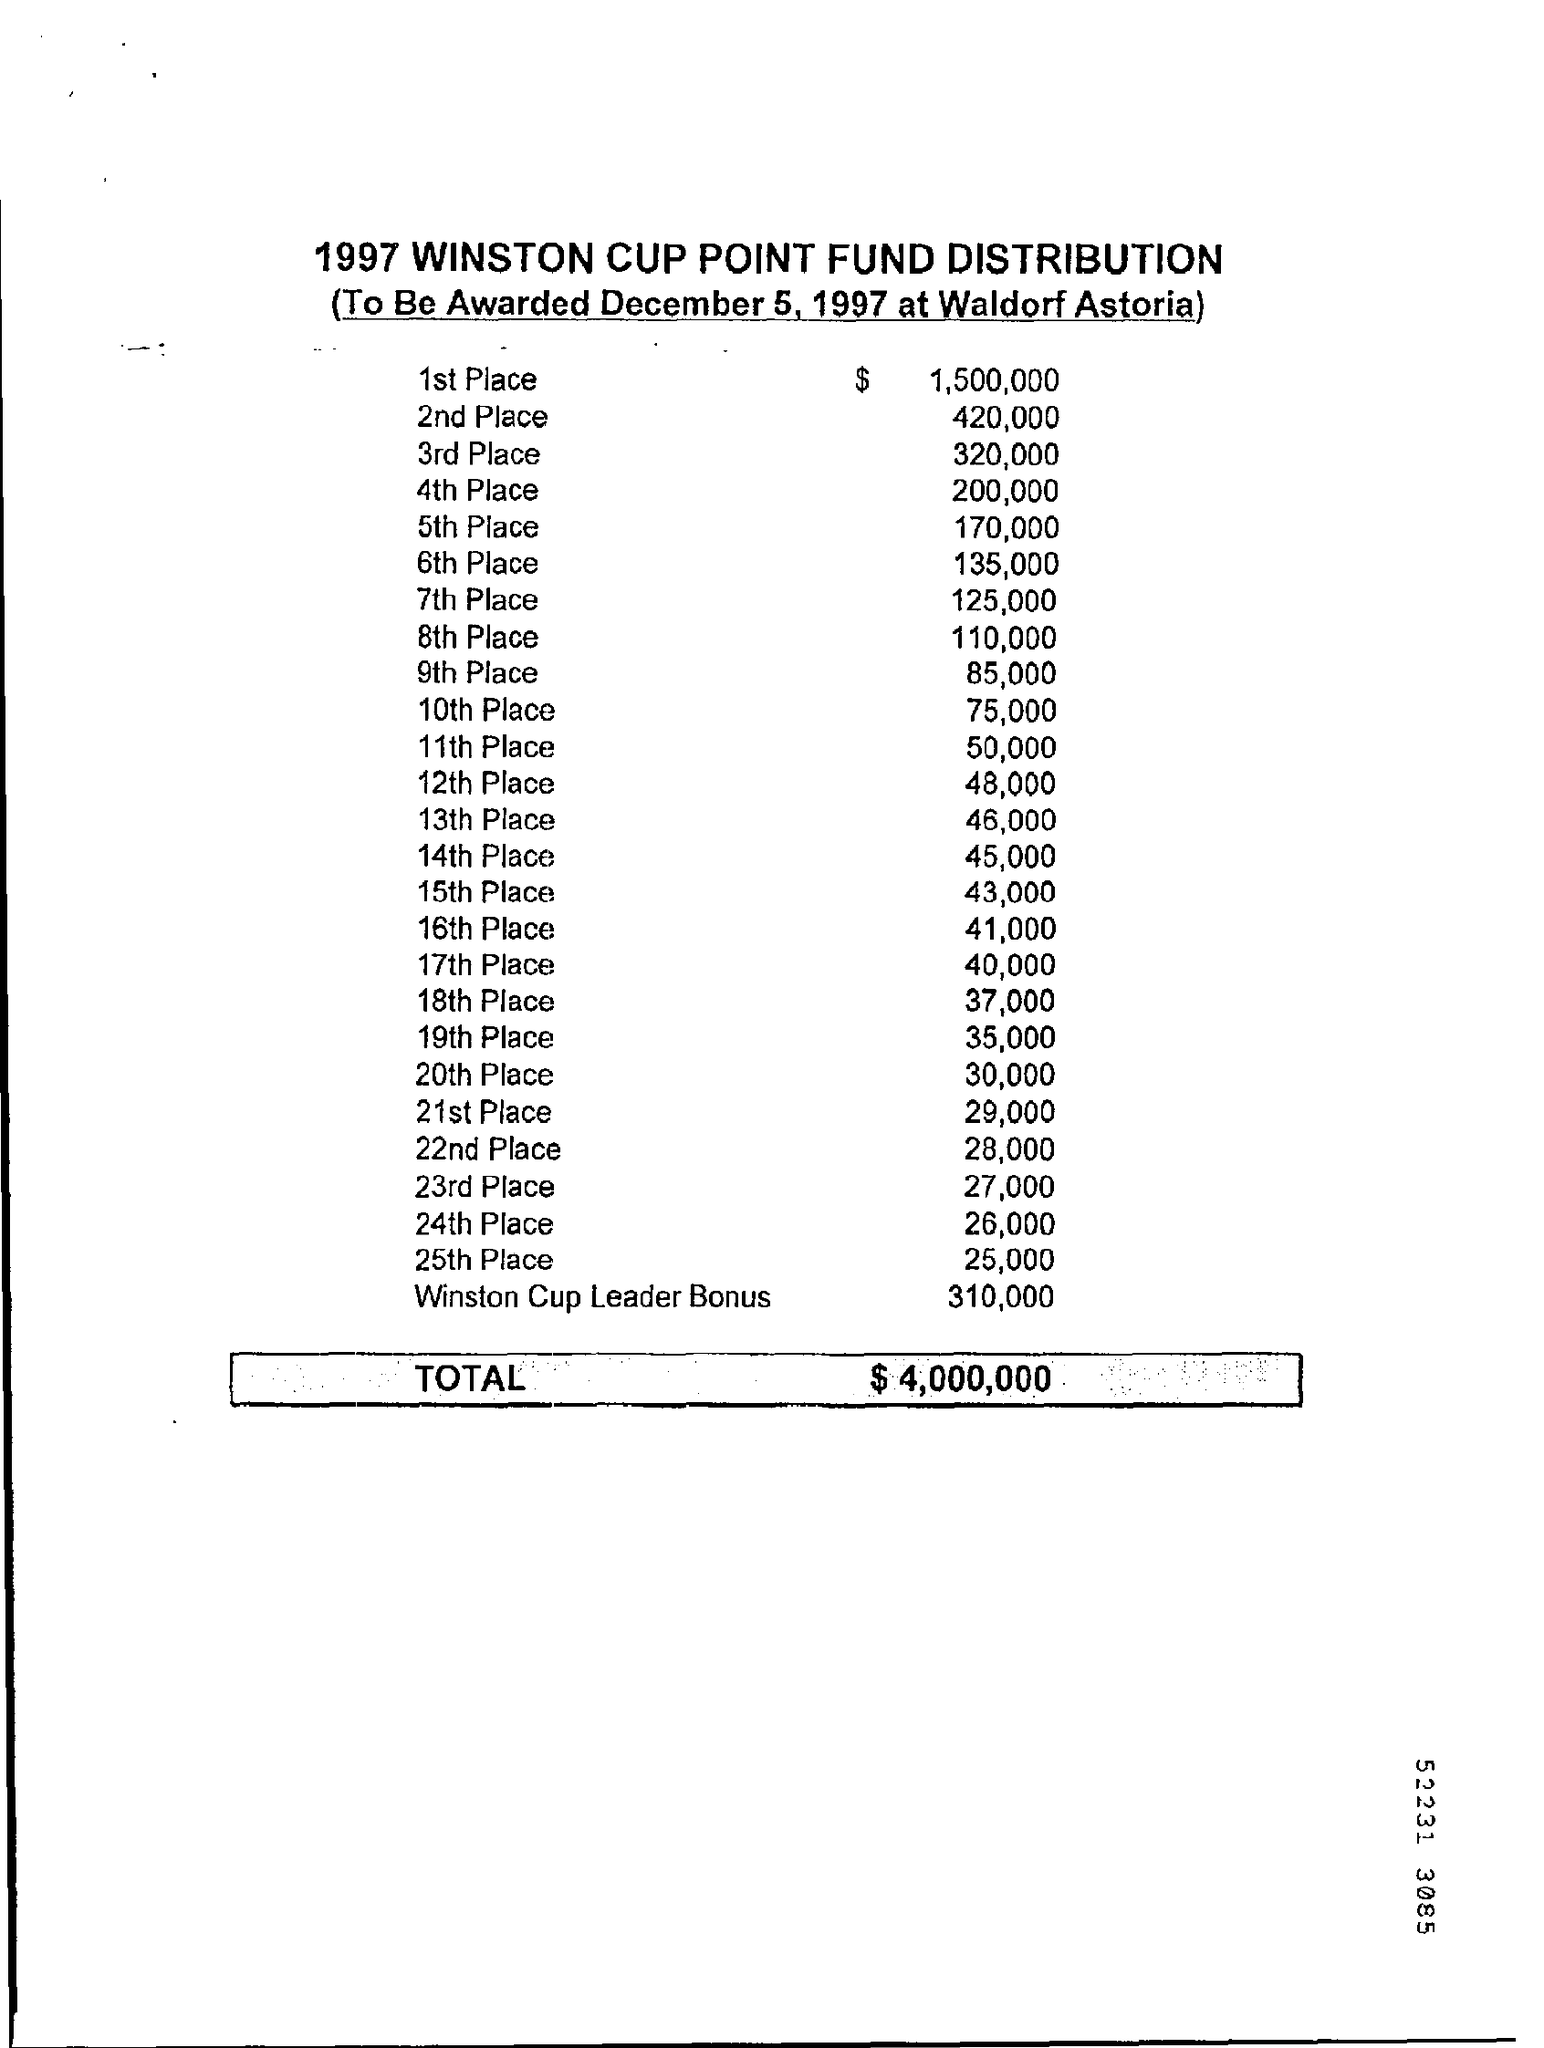Draw attention to some important aspects in this diagram. The 1997 Winston Cup Point Fund Distribution will be awarded at the Waldorf Astoria. The amount paid for the 11th place is $50,000. The distribution of the 1997 Winston Cup points will be awarded on December 5, 1997. The total amount for the 1997 Winston Cup point fund distribution was $4,000,000. The first-place winner received $1,500,000. 